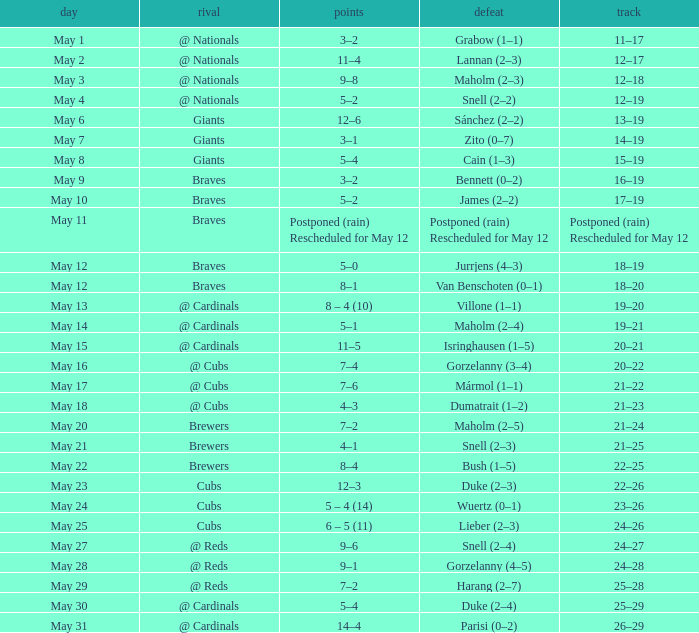Can you parse all the data within this table? {'header': ['day', 'rival', 'points', 'defeat', 'track'], 'rows': [['May 1', '@ Nationals', '3–2', 'Grabow (1–1)', '11–17'], ['May 2', '@ Nationals', '11–4', 'Lannan (2–3)', '12–17'], ['May 3', '@ Nationals', '9–8', 'Maholm (2–3)', '12–18'], ['May 4', '@ Nationals', '5–2', 'Snell (2–2)', '12–19'], ['May 6', 'Giants', '12–6', 'Sánchez (2–2)', '13–19'], ['May 7', 'Giants', '3–1', 'Zito (0–7)', '14–19'], ['May 8', 'Giants', '5–4', 'Cain (1–3)', '15–19'], ['May 9', 'Braves', '3–2', 'Bennett (0–2)', '16–19'], ['May 10', 'Braves', '5–2', 'James (2–2)', '17–19'], ['May 11', 'Braves', 'Postponed (rain) Rescheduled for May 12', 'Postponed (rain) Rescheduled for May 12', 'Postponed (rain) Rescheduled for May 12'], ['May 12', 'Braves', '5–0', 'Jurrjens (4–3)', '18–19'], ['May 12', 'Braves', '8–1', 'Van Benschoten (0–1)', '18–20'], ['May 13', '@ Cardinals', '8 – 4 (10)', 'Villone (1–1)', '19–20'], ['May 14', '@ Cardinals', '5–1', 'Maholm (2–4)', '19–21'], ['May 15', '@ Cardinals', '11–5', 'Isringhausen (1–5)', '20–21'], ['May 16', '@ Cubs', '7–4', 'Gorzelanny (3–4)', '20–22'], ['May 17', '@ Cubs', '7–6', 'Mármol (1–1)', '21–22'], ['May 18', '@ Cubs', '4–3', 'Dumatrait (1–2)', '21–23'], ['May 20', 'Brewers', '7–2', 'Maholm (2–5)', '21–24'], ['May 21', 'Brewers', '4–1', 'Snell (2–3)', '21–25'], ['May 22', 'Brewers', '8–4', 'Bush (1–5)', '22–25'], ['May 23', 'Cubs', '12–3', 'Duke (2–3)', '22–26'], ['May 24', 'Cubs', '5 – 4 (14)', 'Wuertz (0–1)', '23–26'], ['May 25', 'Cubs', '6 – 5 (11)', 'Lieber (2–3)', '24–26'], ['May 27', '@ Reds', '9–6', 'Snell (2–4)', '24–27'], ['May 28', '@ Reds', '9–1', 'Gorzelanny (4–5)', '24–28'], ['May 29', '@ Reds', '7–2', 'Harang (2–7)', '25–28'], ['May 30', '@ Cardinals', '5–4', 'Duke (2–4)', '25–29'], ['May 31', '@ Cardinals', '14–4', 'Parisi (0–2)', '26–29']]} Who was the opponent at the game with a score of 7–6? @ Cubs. 